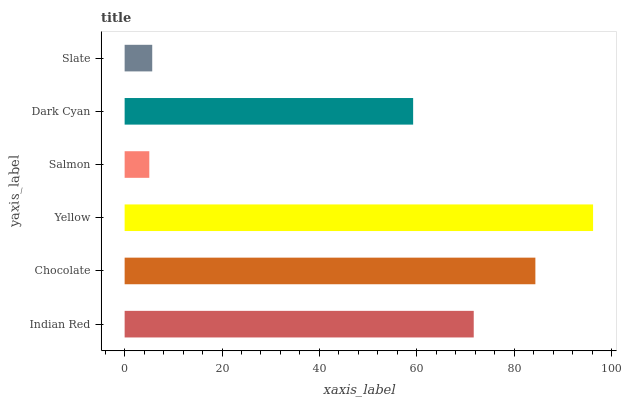Is Salmon the minimum?
Answer yes or no. Yes. Is Yellow the maximum?
Answer yes or no. Yes. Is Chocolate the minimum?
Answer yes or no. No. Is Chocolate the maximum?
Answer yes or no. No. Is Chocolate greater than Indian Red?
Answer yes or no. Yes. Is Indian Red less than Chocolate?
Answer yes or no. Yes. Is Indian Red greater than Chocolate?
Answer yes or no. No. Is Chocolate less than Indian Red?
Answer yes or no. No. Is Indian Red the high median?
Answer yes or no. Yes. Is Dark Cyan the low median?
Answer yes or no. Yes. Is Dark Cyan the high median?
Answer yes or no. No. Is Chocolate the low median?
Answer yes or no. No. 